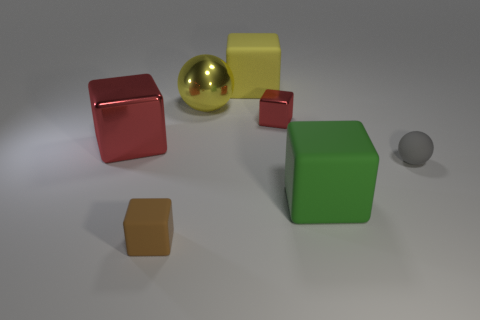There is a big object that is on the left side of the large sphere; is it the same shape as the green thing?
Keep it short and to the point. Yes. There is a small object to the right of the green matte block; what shape is it?
Your answer should be compact. Sphere. The other cube that is the same color as the tiny shiny cube is what size?
Your response must be concise. Large. What is the big yellow sphere made of?
Your answer should be very brief. Metal. What is the color of the metal ball that is the same size as the yellow rubber thing?
Offer a terse response. Yellow. What is the shape of the big matte thing that is the same color as the big metallic sphere?
Your answer should be very brief. Cube. Is the green object the same shape as the yellow metal object?
Provide a succinct answer. No. What is the material of the big thing that is both behind the small matte sphere and on the right side of the large yellow metal sphere?
Keep it short and to the point. Rubber. The brown block has what size?
Ensure brevity in your answer.  Small. There is another shiny object that is the same shape as the tiny red thing; what color is it?
Give a very brief answer. Red. 